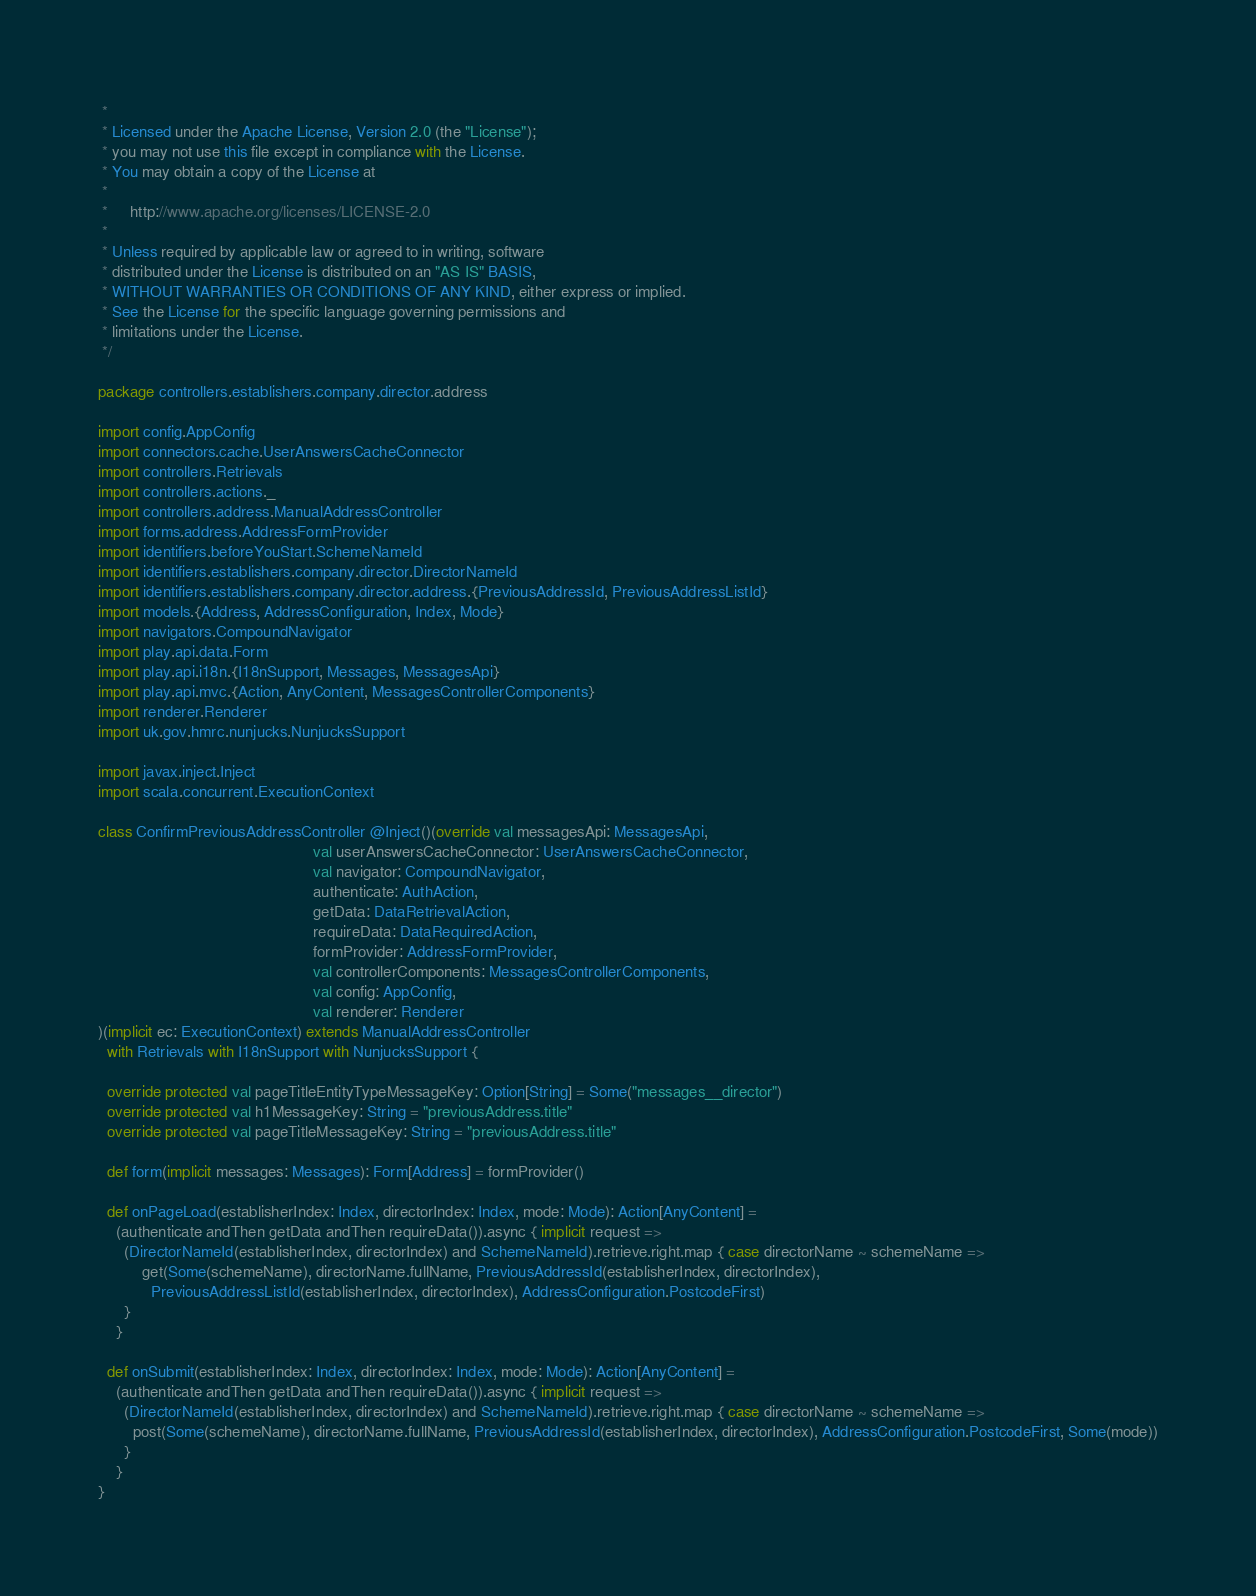<code> <loc_0><loc_0><loc_500><loc_500><_Scala_> *
 * Licensed under the Apache License, Version 2.0 (the "License");
 * you may not use this file except in compliance with the License.
 * You may obtain a copy of the License at
 *
 *     http://www.apache.org/licenses/LICENSE-2.0
 *
 * Unless required by applicable law or agreed to in writing, software
 * distributed under the License is distributed on an "AS IS" BASIS,
 * WITHOUT WARRANTIES OR CONDITIONS OF ANY KIND, either express or implied.
 * See the License for the specific language governing permissions and
 * limitations under the License.
 */

package controllers.establishers.company.director.address

import config.AppConfig
import connectors.cache.UserAnswersCacheConnector
import controllers.Retrievals
import controllers.actions._
import controllers.address.ManualAddressController
import forms.address.AddressFormProvider
import identifiers.beforeYouStart.SchemeNameId
import identifiers.establishers.company.director.DirectorNameId
import identifiers.establishers.company.director.address.{PreviousAddressId, PreviousAddressListId}
import models.{Address, AddressConfiguration, Index, Mode}
import navigators.CompoundNavigator
import play.api.data.Form
import play.api.i18n.{I18nSupport, Messages, MessagesApi}
import play.api.mvc.{Action, AnyContent, MessagesControllerComponents}
import renderer.Renderer
import uk.gov.hmrc.nunjucks.NunjucksSupport

import javax.inject.Inject
import scala.concurrent.ExecutionContext

class ConfirmPreviousAddressController @Inject()(override val messagesApi: MessagesApi,
                                                 val userAnswersCacheConnector: UserAnswersCacheConnector,
                                                 val navigator: CompoundNavigator,
                                                 authenticate: AuthAction,
                                                 getData: DataRetrievalAction,
                                                 requireData: DataRequiredAction,
                                                 formProvider: AddressFormProvider,
                                                 val controllerComponents: MessagesControllerComponents,
                                                 val config: AppConfig,
                                                 val renderer: Renderer
)(implicit ec: ExecutionContext) extends ManualAddressController
  with Retrievals with I18nSupport with NunjucksSupport {

  override protected val pageTitleEntityTypeMessageKey: Option[String] = Some("messages__director")
  override protected val h1MessageKey: String = "previousAddress.title"
  override protected val pageTitleMessageKey: String = "previousAddress.title"

  def form(implicit messages: Messages): Form[Address] = formProvider()

  def onPageLoad(establisherIndex: Index, directorIndex: Index, mode: Mode): Action[AnyContent] =
    (authenticate andThen getData andThen requireData()).async { implicit request =>
      (DirectorNameId(establisherIndex, directorIndex) and SchemeNameId).retrieve.right.map { case directorName ~ schemeName =>
          get(Some(schemeName), directorName.fullName, PreviousAddressId(establisherIndex, directorIndex),
            PreviousAddressListId(establisherIndex, directorIndex), AddressConfiguration.PostcodeFirst)
      }
    }

  def onSubmit(establisherIndex: Index, directorIndex: Index, mode: Mode): Action[AnyContent] =
    (authenticate andThen getData andThen requireData()).async { implicit request =>
      (DirectorNameId(establisherIndex, directorIndex) and SchemeNameId).retrieve.right.map { case directorName ~ schemeName =>
        post(Some(schemeName), directorName.fullName, PreviousAddressId(establisherIndex, directorIndex), AddressConfiguration.PostcodeFirst, Some(mode))
      }
    }
}
</code> 